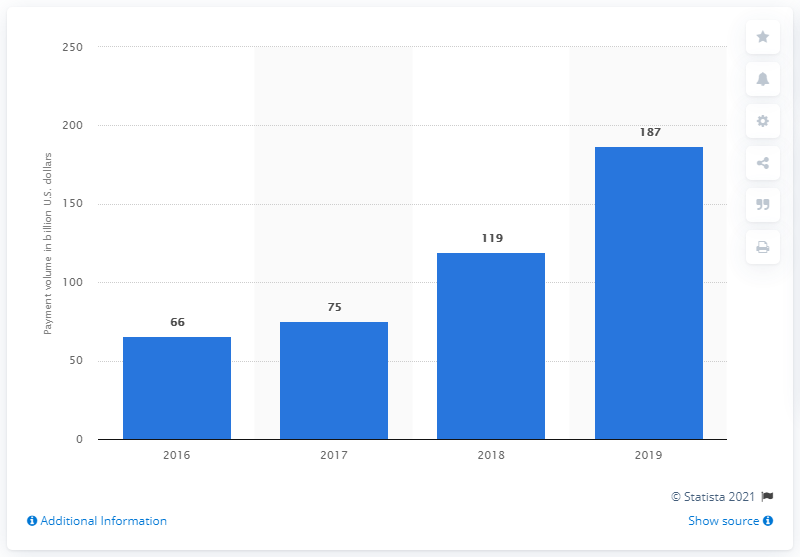List a handful of essential elements in this visual. During the period of 2016 to 2019, Zelle moved a total of 187 dollars through its payment network. 